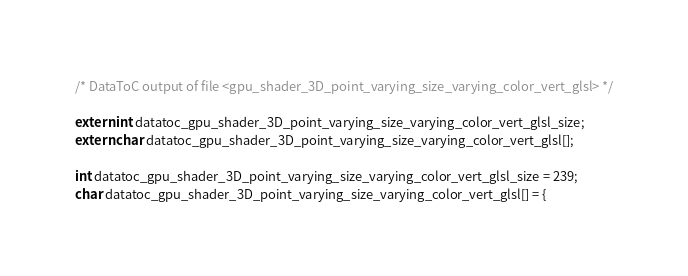Convert code to text. <code><loc_0><loc_0><loc_500><loc_500><_C_>/* DataToC output of file <gpu_shader_3D_point_varying_size_varying_color_vert_glsl> */

extern int datatoc_gpu_shader_3D_point_varying_size_varying_color_vert_glsl_size;
extern char datatoc_gpu_shader_3D_point_varying_size_varying_color_vert_glsl[];

int datatoc_gpu_shader_3D_point_varying_size_varying_color_vert_glsl_size = 239;
char datatoc_gpu_shader_3D_point_varying_size_varying_color_vert_glsl[] = {</code> 